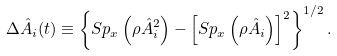Convert formula to latex. <formula><loc_0><loc_0><loc_500><loc_500>\Delta \hat { A } _ { i } ( t ) \equiv \left \{ S p _ { x } \left ( \rho \hat { A } _ { i } ^ { 2 } \right ) - \left [ S p _ { x } \left ( \rho \hat { A } _ { i } \right ) \right ] ^ { 2 } \right \} ^ { 1 / 2 } .</formula> 